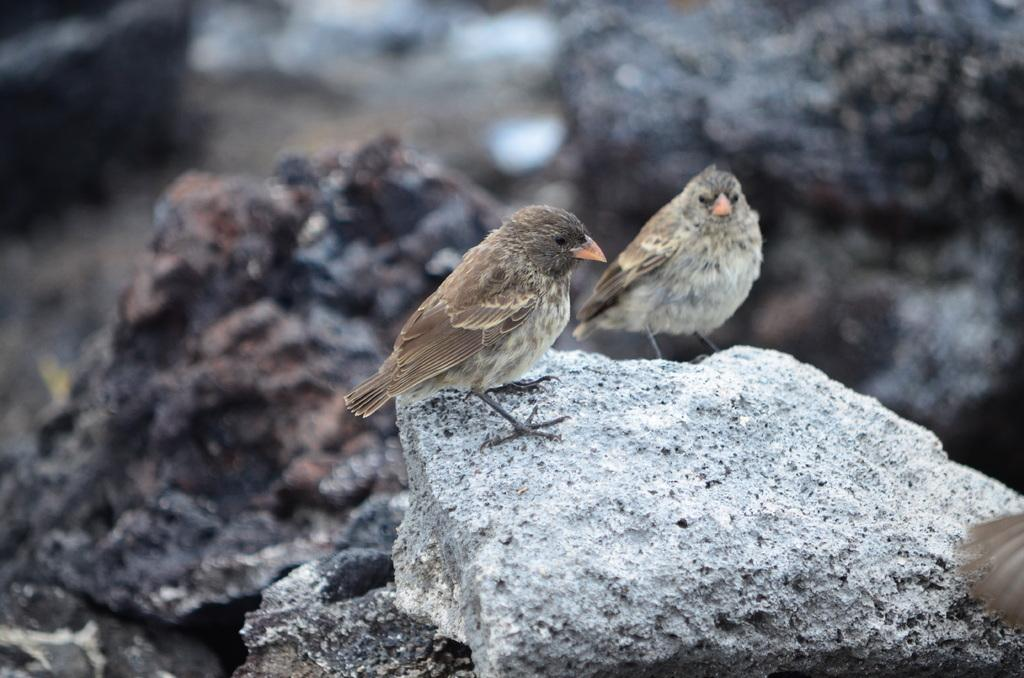How many birds are in the image? There are two birds in the image. What are the birds standing on? The birds are standing on rocks. Are there any other rocks visible in the image? Yes, there are rocks visible behind the birds. What type of fear can be seen on the face of the frog in the image? There is no frog present in the image, so it is not possible to determine if there is any fear or emotion on its face. 